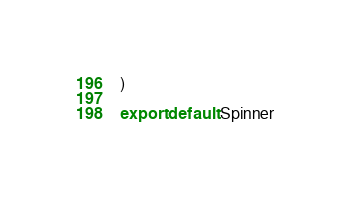Convert code to text. <code><loc_0><loc_0><loc_500><loc_500><_JavaScript_>)

export default Spinner
</code> 